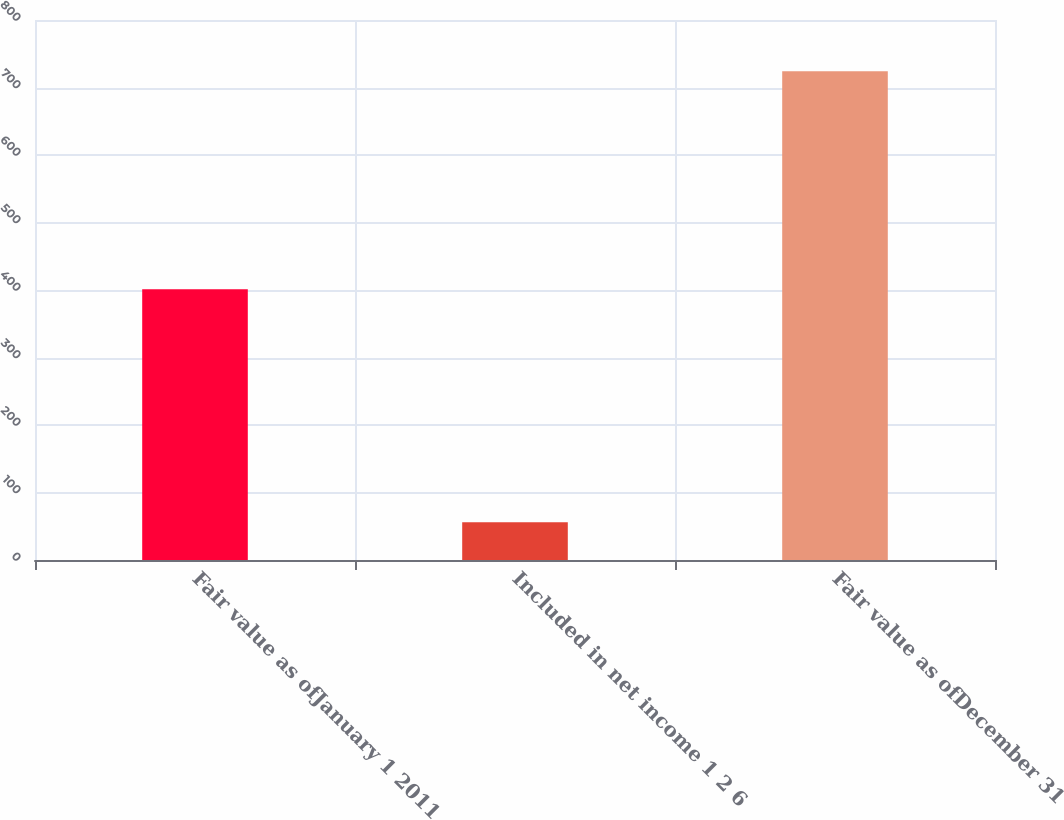Convert chart to OTSL. <chart><loc_0><loc_0><loc_500><loc_500><bar_chart><fcel>Fair value as ofJanuary 1 2011<fcel>Included in net income 1 2 6<fcel>Fair value as ofDecember 31<nl><fcel>401<fcel>56<fcel>724<nl></chart> 